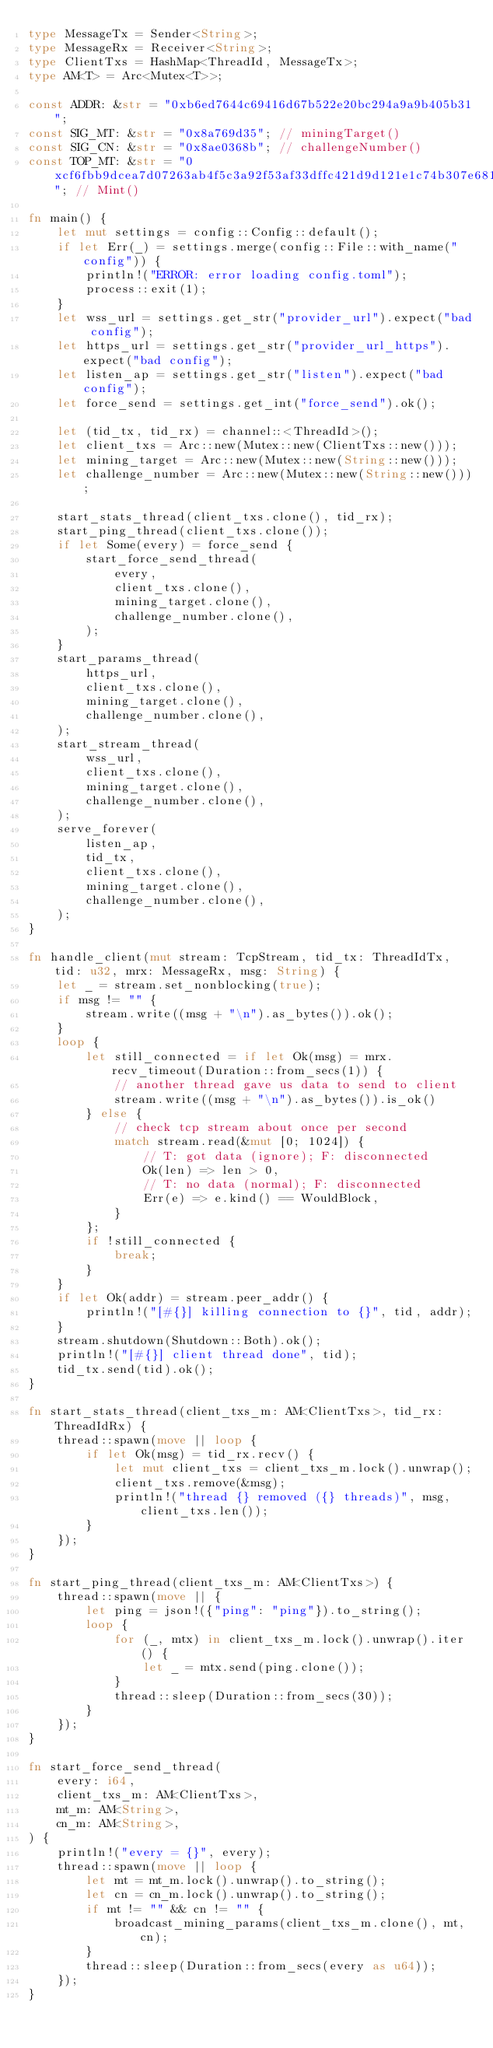<code> <loc_0><loc_0><loc_500><loc_500><_Rust_>type MessageTx = Sender<String>;
type MessageRx = Receiver<String>;
type ClientTxs = HashMap<ThreadId, MessageTx>;
type AM<T> = Arc<Mutex<T>>;

const ADDR: &str = "0xb6ed7644c69416d67b522e20bc294a9a9b405b31";
const SIG_MT: &str = "0x8a769d35"; // miningTarget()
const SIG_CN: &str = "0x8ae0368b"; // challengeNumber()
const TOP_MT: &str = "0xcf6fbb9dcea7d07263ab4f5c3a92f53af33dffc421d9d121e1c74b307e68189d"; // Mint()

fn main() {
    let mut settings = config::Config::default();
    if let Err(_) = settings.merge(config::File::with_name("config")) {
        println!("ERROR: error loading config.toml");
        process::exit(1);
    }
    let wss_url = settings.get_str("provider_url").expect("bad config");
    let https_url = settings.get_str("provider_url_https").expect("bad config");
    let listen_ap = settings.get_str("listen").expect("bad config");
    let force_send = settings.get_int("force_send").ok();

    let (tid_tx, tid_rx) = channel::<ThreadId>();
    let client_txs = Arc::new(Mutex::new(ClientTxs::new()));
    let mining_target = Arc::new(Mutex::new(String::new()));
    let challenge_number = Arc::new(Mutex::new(String::new()));

    start_stats_thread(client_txs.clone(), tid_rx);
    start_ping_thread(client_txs.clone());
    if let Some(every) = force_send {
        start_force_send_thread(
            every,
            client_txs.clone(),
            mining_target.clone(),
            challenge_number.clone(),
        );
    }
    start_params_thread(
        https_url,
        client_txs.clone(),
        mining_target.clone(),
        challenge_number.clone(),
    );
    start_stream_thread(
        wss_url,
        client_txs.clone(),
        mining_target.clone(),
        challenge_number.clone(),
    );
    serve_forever(
        listen_ap,
        tid_tx,
        client_txs.clone(),
        mining_target.clone(),
        challenge_number.clone(),
    );
}

fn handle_client(mut stream: TcpStream, tid_tx: ThreadIdTx, tid: u32, mrx: MessageRx, msg: String) {
    let _ = stream.set_nonblocking(true);
    if msg != "" {
        stream.write((msg + "\n").as_bytes()).ok();
    }
    loop {
        let still_connected = if let Ok(msg) = mrx.recv_timeout(Duration::from_secs(1)) {
            // another thread gave us data to send to client
            stream.write((msg + "\n").as_bytes()).is_ok()
        } else {
            // check tcp stream about once per second
            match stream.read(&mut [0; 1024]) {
                // T: got data (ignore); F: disconnected
                Ok(len) => len > 0,
                // T: no data (normal); F: disconnected
                Err(e) => e.kind() == WouldBlock,
            }
        };
        if !still_connected {
            break;
        }
    }
    if let Ok(addr) = stream.peer_addr() {
        println!("[#{}] killing connection to {}", tid, addr);
    }
    stream.shutdown(Shutdown::Both).ok();
    println!("[#{}] client thread done", tid);
    tid_tx.send(tid).ok();
}

fn start_stats_thread(client_txs_m: AM<ClientTxs>, tid_rx: ThreadIdRx) {
    thread::spawn(move || loop {
        if let Ok(msg) = tid_rx.recv() {
            let mut client_txs = client_txs_m.lock().unwrap();
            client_txs.remove(&msg);
            println!("thread {} removed ({} threads)", msg, client_txs.len());
        }
    });
}

fn start_ping_thread(client_txs_m: AM<ClientTxs>) {
    thread::spawn(move || {
        let ping = json!({"ping": "ping"}).to_string();
        loop {
            for (_, mtx) in client_txs_m.lock().unwrap().iter() {
                let _ = mtx.send(ping.clone());
            }
            thread::sleep(Duration::from_secs(30));
        }
    });
}

fn start_force_send_thread(
    every: i64,
    client_txs_m: AM<ClientTxs>,
    mt_m: AM<String>,
    cn_m: AM<String>,
) {
    println!("every = {}", every);
    thread::spawn(move || loop {
        let mt = mt_m.lock().unwrap().to_string();
        let cn = cn_m.lock().unwrap().to_string();
        if mt != "" && cn != "" {
            broadcast_mining_params(client_txs_m.clone(), mt, cn);
        }
        thread::sleep(Duration::from_secs(every as u64));
    });
}
</code> 